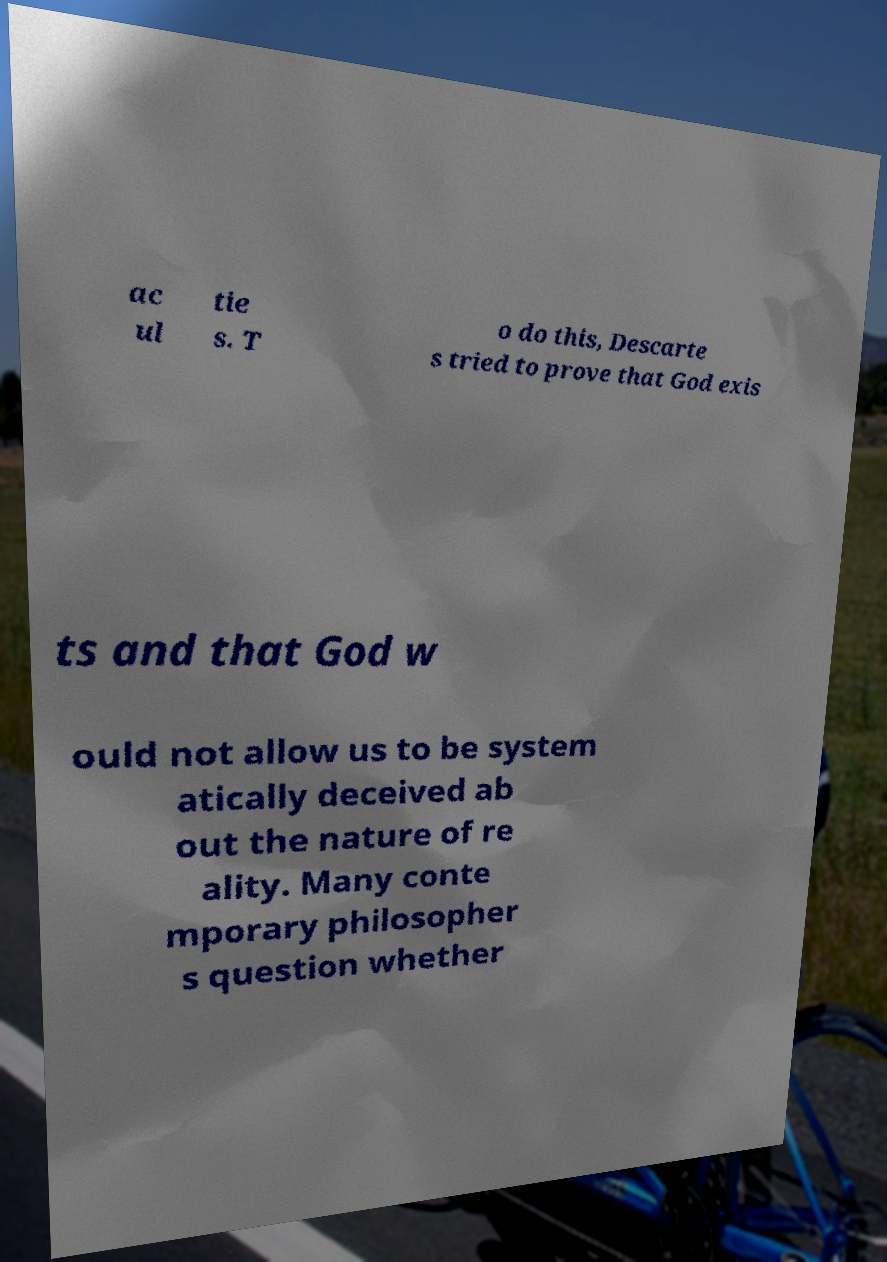Could you extract and type out the text from this image? ac ul tie s. T o do this, Descarte s tried to prove that God exis ts and that God w ould not allow us to be system atically deceived ab out the nature of re ality. Many conte mporary philosopher s question whether 